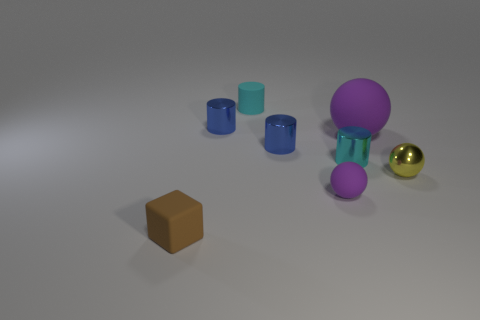What number of blue shiny objects have the same shape as the big matte object?
Your answer should be compact. 0. How many matte cylinders have the same size as the cyan shiny cylinder?
Provide a succinct answer. 1. There is a tiny yellow thing that is the same shape as the large rubber object; what material is it?
Keep it short and to the point. Metal. There is a ball that is in front of the tiny yellow object; what color is it?
Your answer should be very brief. Purple. Are there more tiny brown rubber objects that are behind the small matte sphere than small rubber blocks?
Give a very brief answer. No. The tiny metal sphere has what color?
Ensure brevity in your answer.  Yellow. What is the shape of the tiny matte thing behind the small metallic object that is to the right of the ball behind the tiny yellow metallic sphere?
Your answer should be compact. Cylinder. What is the material of the sphere that is both on the right side of the tiny purple sphere and in front of the big ball?
Provide a short and direct response. Metal. There is a small thing to the right of the sphere behind the tiny yellow ball; what is its shape?
Offer a terse response. Sphere. Are there any other things that are the same color as the metal ball?
Provide a short and direct response. No. 